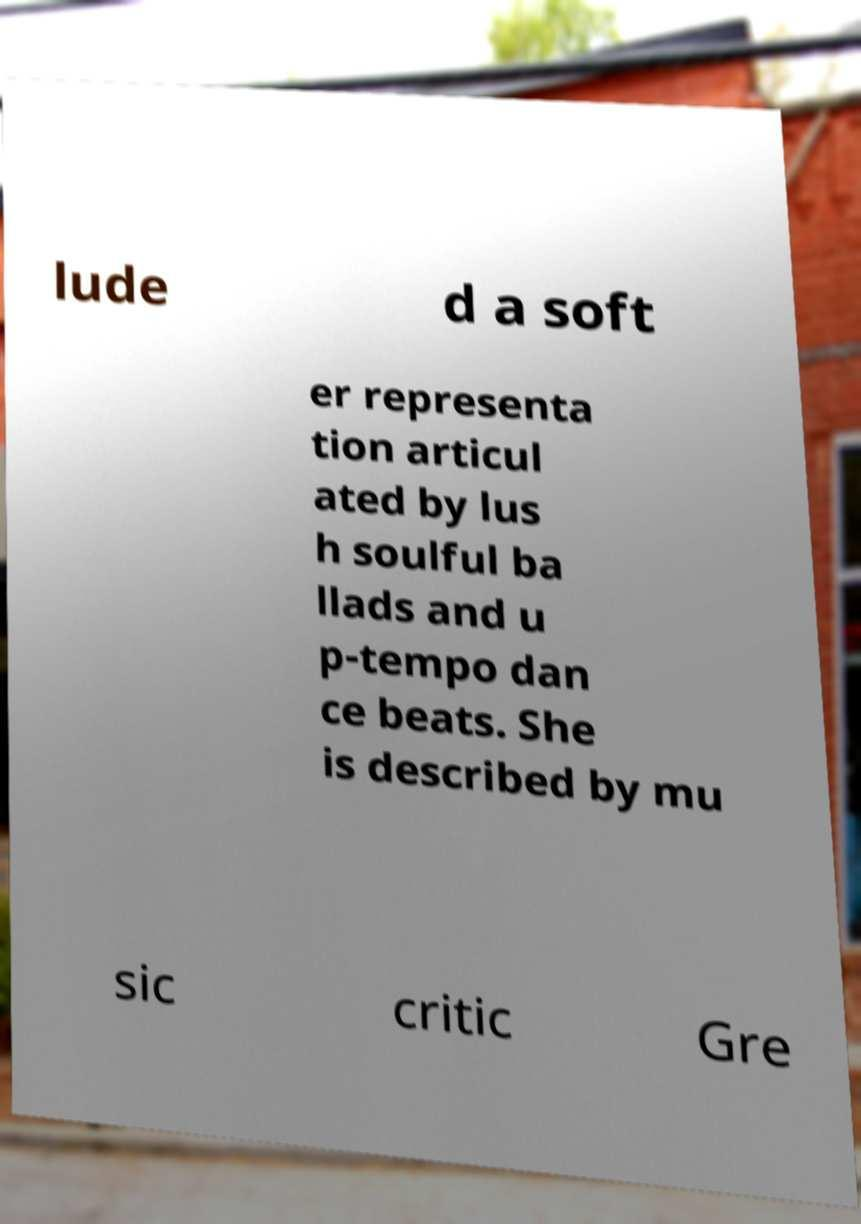What messages or text are displayed in this image? I need them in a readable, typed format. lude d a soft er representa tion articul ated by lus h soulful ba llads and u p-tempo dan ce beats. She is described by mu sic critic Gre 